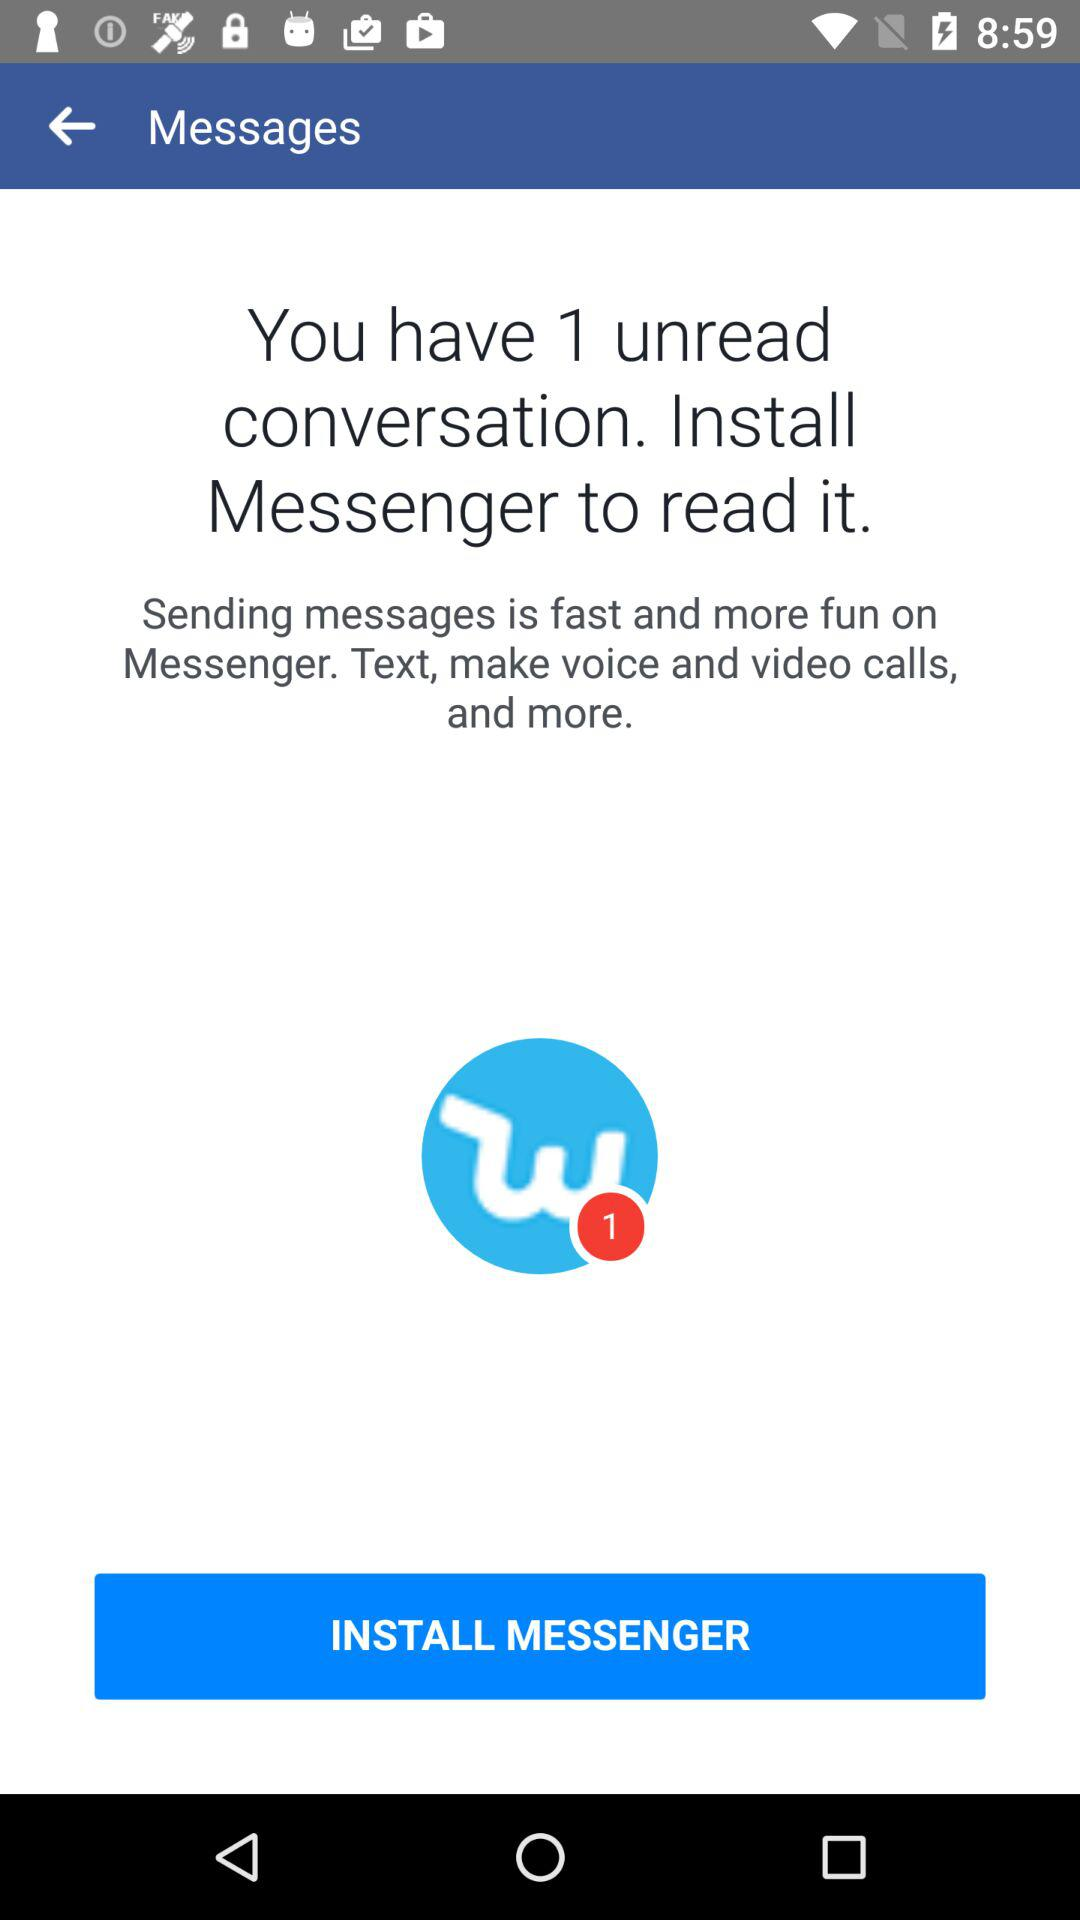In which application is sending messages faster and more fun? Sending messages is faster and more fun in the "Messenger" application. 